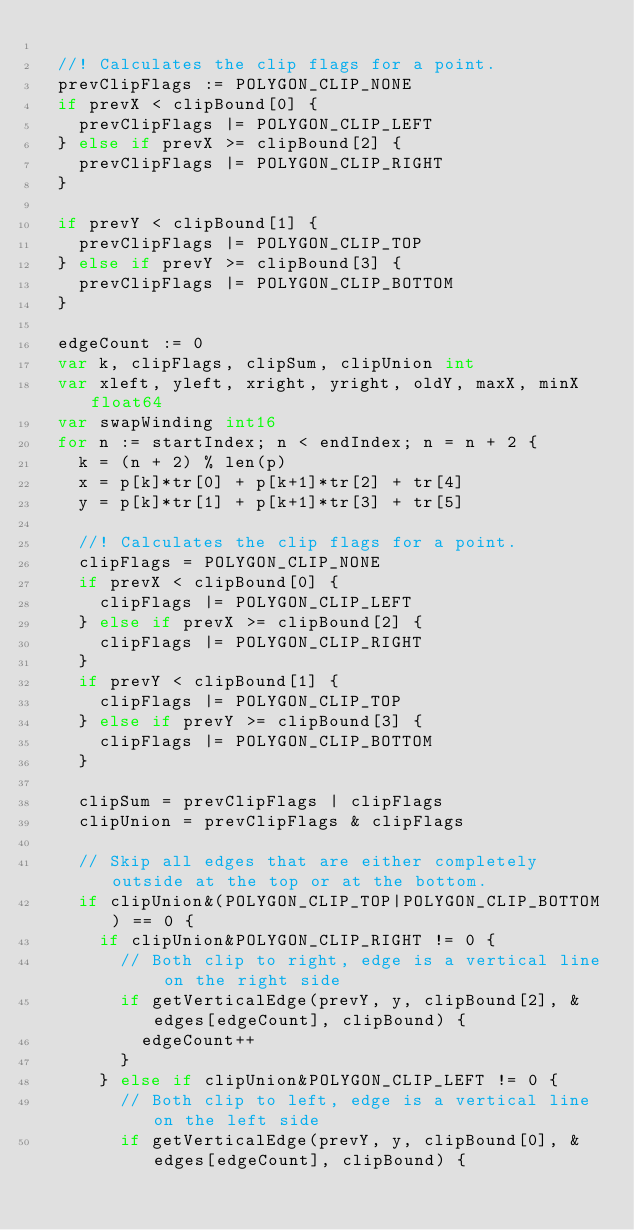<code> <loc_0><loc_0><loc_500><loc_500><_Go_>
	//! Calculates the clip flags for a point.
	prevClipFlags := POLYGON_CLIP_NONE
	if prevX < clipBound[0] {
		prevClipFlags |= POLYGON_CLIP_LEFT
	} else if prevX >= clipBound[2] {
		prevClipFlags |= POLYGON_CLIP_RIGHT
	}

	if prevY < clipBound[1] {
		prevClipFlags |= POLYGON_CLIP_TOP
	} else if prevY >= clipBound[3] {
		prevClipFlags |= POLYGON_CLIP_BOTTOM
	}

	edgeCount := 0
	var k, clipFlags, clipSum, clipUnion int
	var xleft, yleft, xright, yright, oldY, maxX, minX float64
	var swapWinding int16
	for n := startIndex; n < endIndex; n = n + 2 {
		k = (n + 2) % len(p)
		x = p[k]*tr[0] + p[k+1]*tr[2] + tr[4]
		y = p[k]*tr[1] + p[k+1]*tr[3] + tr[5]

		//! Calculates the clip flags for a point.
		clipFlags = POLYGON_CLIP_NONE
		if prevX < clipBound[0] {
			clipFlags |= POLYGON_CLIP_LEFT
		} else if prevX >= clipBound[2] {
			clipFlags |= POLYGON_CLIP_RIGHT
		}
		if prevY < clipBound[1] {
			clipFlags |= POLYGON_CLIP_TOP
		} else if prevY >= clipBound[3] {
			clipFlags |= POLYGON_CLIP_BOTTOM
		}

		clipSum = prevClipFlags | clipFlags
		clipUnion = prevClipFlags & clipFlags

		// Skip all edges that are either completely outside at the top or at the bottom.
		if clipUnion&(POLYGON_CLIP_TOP|POLYGON_CLIP_BOTTOM) == 0 {
			if clipUnion&POLYGON_CLIP_RIGHT != 0 {
				// Both clip to right, edge is a vertical line on the right side
				if getVerticalEdge(prevY, y, clipBound[2], &edges[edgeCount], clipBound) {
					edgeCount++
				}
			} else if clipUnion&POLYGON_CLIP_LEFT != 0 {
				// Both clip to left, edge is a vertical line on the left side
				if getVerticalEdge(prevY, y, clipBound[0], &edges[edgeCount], clipBound) {</code> 